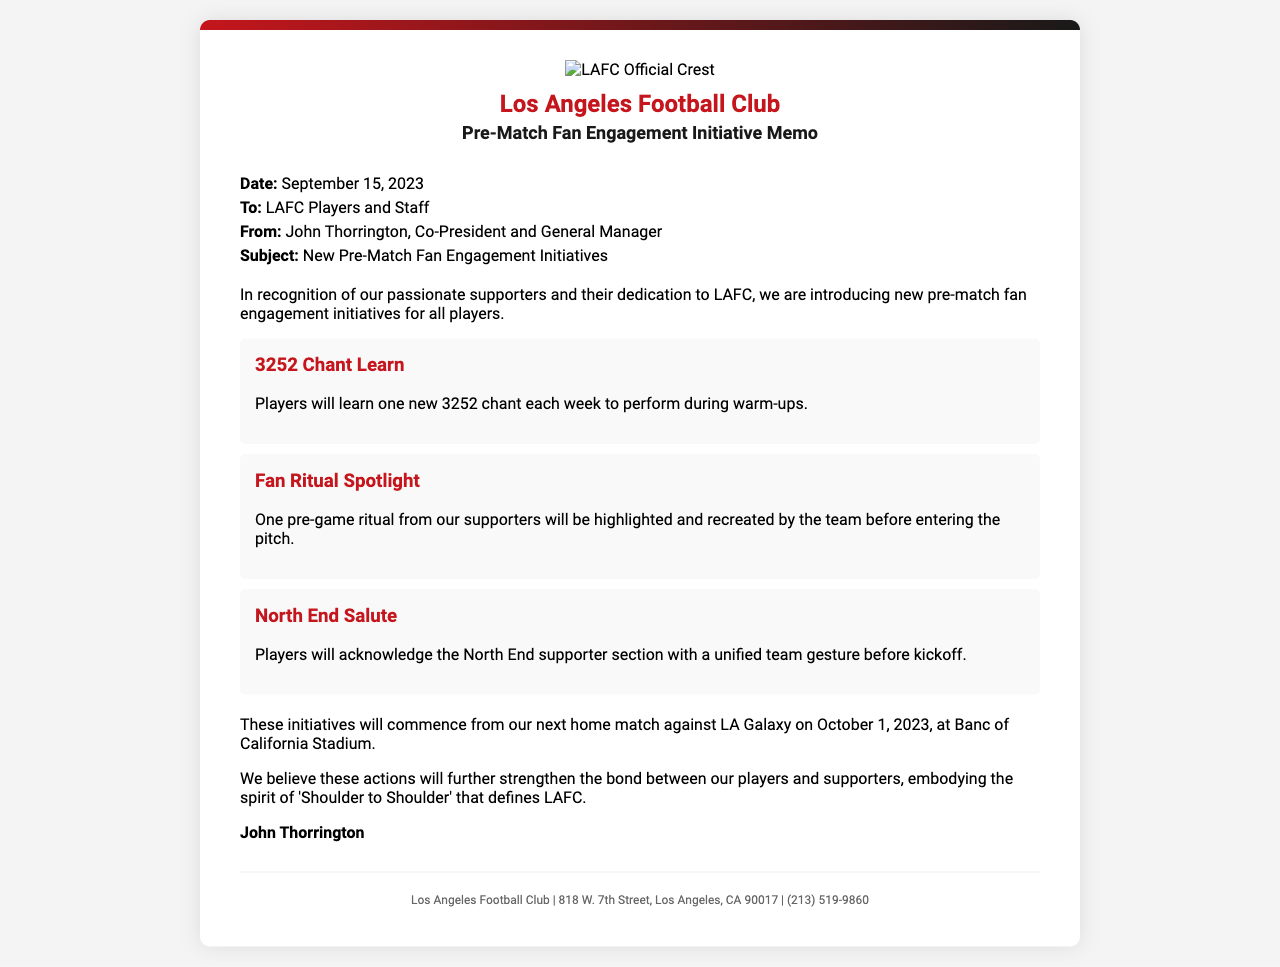what is the date of the memo? The memo is dated September 15, 2023.
Answer: September 15, 2023 who is the sender of the memo? The sender of the memo is John Thorrington, Co-President and General Manager.
Answer: John Thorrington what is the subject of the memo? The subject of the memo is about new pre-match fan engagement initiatives.
Answer: New Pre-Match Fan Engagement Initiatives what is one of the initiatives mentioned? One initiative is "3252 Chant Learn," where players will learn a new chant each week.
Answer: 3252 Chant Learn when will the initiatives commence? The initiatives will commence from the next home match against LA Galaxy.
Answer: October 1, 2023 what is the purpose of these initiatives? The purpose is to strengthen the bond between players and supporters.
Answer: Strengthen the bond who is the memo addressed to? The memo is addressed to LAFC Players and Staff.
Answer: LAFC Players and Staff how will players acknowledge the North End supporter section? Players will acknowledge the North End with a unified team gesture.
Answer: Unified team gesture what is the location of the next home match? The location of the next home match is Banc of California Stadium.
Answer: Banc of California Stadium 